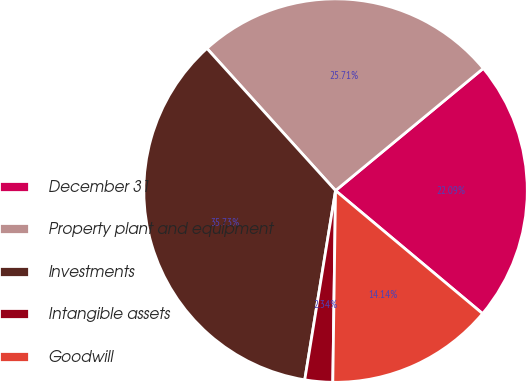Convert chart. <chart><loc_0><loc_0><loc_500><loc_500><pie_chart><fcel>December 31<fcel>Property plant and equipment<fcel>Investments<fcel>Intangible assets<fcel>Goodwill<nl><fcel>22.09%<fcel>25.71%<fcel>35.73%<fcel>2.34%<fcel>14.14%<nl></chart> 